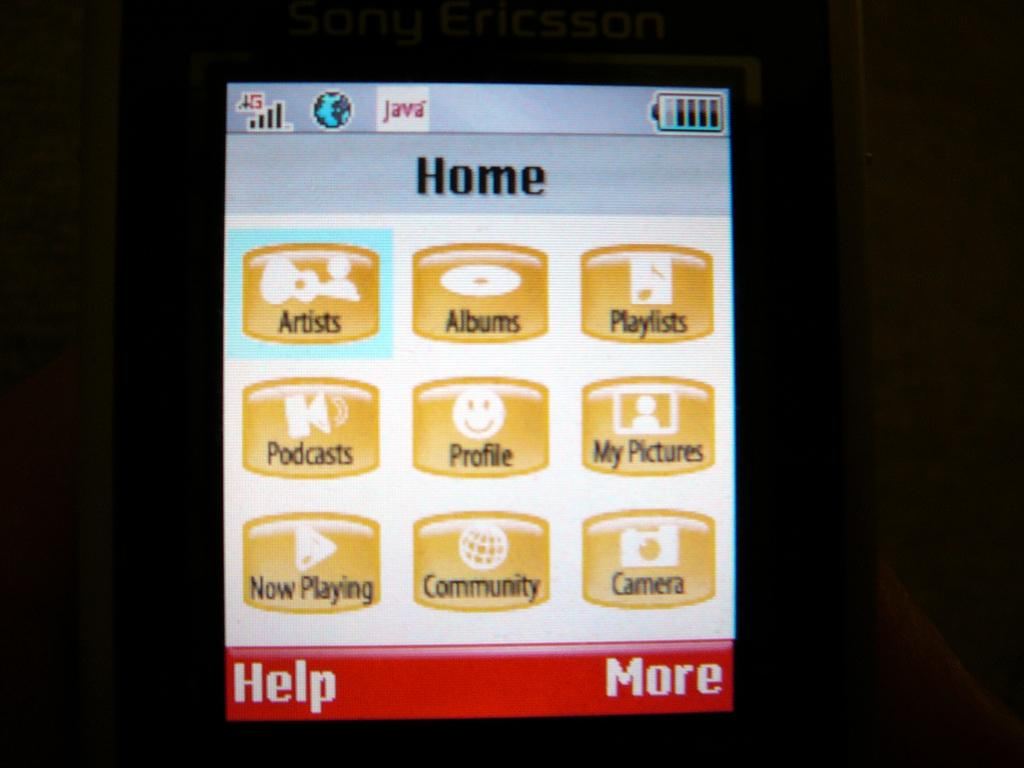<image>
Summarize the visual content of the image. Phone screen that says Home on the top. 